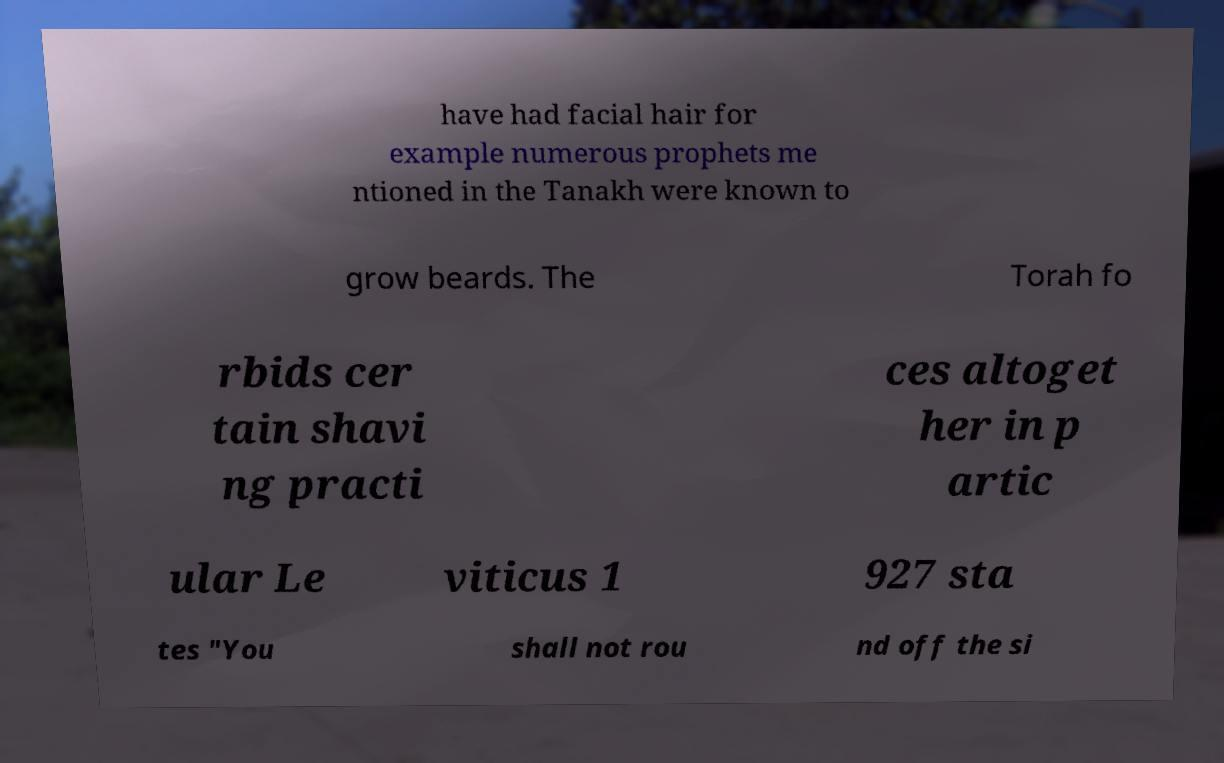Could you assist in decoding the text presented in this image and type it out clearly? have had facial hair for example numerous prophets me ntioned in the Tanakh were known to grow beards. The Torah fo rbids cer tain shavi ng practi ces altoget her in p artic ular Le viticus 1 927 sta tes "You shall not rou nd off the si 